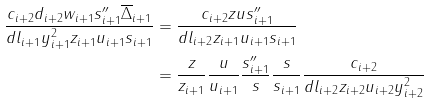<formula> <loc_0><loc_0><loc_500><loc_500>\frac { c _ { i + 2 } d _ { i + 2 } w _ { i + 1 } s _ { i + 1 } ^ { \prime \prime } \overline { \Delta } _ { i + 1 } } { d l _ { i + 1 } y _ { i + 1 } ^ { 2 } z _ { i + 1 } u _ { i + 1 } s _ { i + 1 } } & = \frac { c _ { i + 2 } z u s _ { i + 1 } ^ { \prime \prime } } { d l _ { i + 2 } z _ { i + 1 } u _ { i + 1 } s _ { i + 1 } } \\ & = \frac { z } { z _ { i + 1 } } \frac { u } { u _ { i + 1 } } \frac { s _ { i + 1 } ^ { \prime \prime } } { s } \frac { s } { s _ { i + 1 } } \frac { c _ { i + 2 } } { d l _ { i + 2 } z _ { i + 2 } u _ { i + 2 } y _ { i + 2 } ^ { 2 } }</formula> 